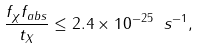Convert formula to latex. <formula><loc_0><loc_0><loc_500><loc_500>\frac { f _ { \chi } f _ { a b s } } { t _ { X } } \leq 2 . 4 \times 1 0 ^ { - 2 5 } \ s ^ { - 1 } ,</formula> 